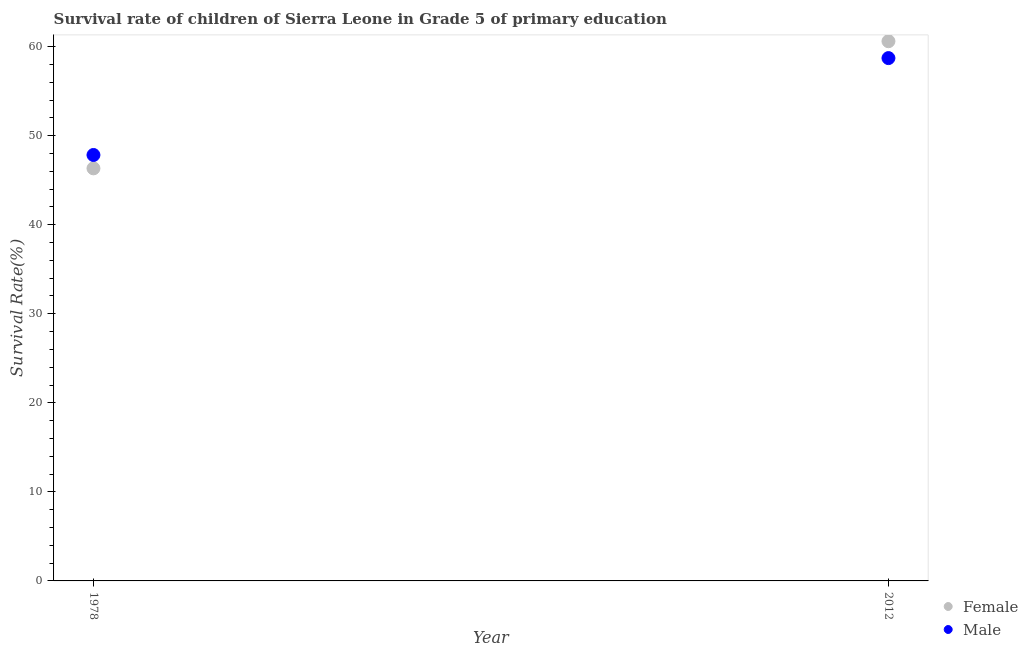How many different coloured dotlines are there?
Ensure brevity in your answer.  2. Is the number of dotlines equal to the number of legend labels?
Provide a succinct answer. Yes. What is the survival rate of female students in primary education in 2012?
Ensure brevity in your answer.  60.6. Across all years, what is the maximum survival rate of female students in primary education?
Offer a terse response. 60.6. Across all years, what is the minimum survival rate of female students in primary education?
Provide a short and direct response. 46.33. In which year was the survival rate of female students in primary education minimum?
Provide a succinct answer. 1978. What is the total survival rate of female students in primary education in the graph?
Your response must be concise. 106.93. What is the difference between the survival rate of male students in primary education in 1978 and that in 2012?
Ensure brevity in your answer.  -10.88. What is the difference between the survival rate of female students in primary education in 1978 and the survival rate of male students in primary education in 2012?
Provide a short and direct response. -12.38. What is the average survival rate of female students in primary education per year?
Provide a short and direct response. 53.47. In the year 1978, what is the difference between the survival rate of male students in primary education and survival rate of female students in primary education?
Make the answer very short. 1.5. What is the ratio of the survival rate of female students in primary education in 1978 to that in 2012?
Offer a terse response. 0.76. Is the survival rate of female students in primary education in 1978 less than that in 2012?
Your response must be concise. Yes. In how many years, is the survival rate of male students in primary education greater than the average survival rate of male students in primary education taken over all years?
Provide a short and direct response. 1. Does the survival rate of female students in primary education monotonically increase over the years?
Keep it short and to the point. Yes. Is the survival rate of male students in primary education strictly greater than the survival rate of female students in primary education over the years?
Give a very brief answer. No. How many dotlines are there?
Make the answer very short. 2. What is the difference between two consecutive major ticks on the Y-axis?
Your answer should be very brief. 10. Are the values on the major ticks of Y-axis written in scientific E-notation?
Ensure brevity in your answer.  No. Does the graph contain grids?
Your answer should be compact. No. How many legend labels are there?
Give a very brief answer. 2. How are the legend labels stacked?
Provide a succinct answer. Vertical. What is the title of the graph?
Offer a very short reply. Survival rate of children of Sierra Leone in Grade 5 of primary education. What is the label or title of the Y-axis?
Provide a succinct answer. Survival Rate(%). What is the Survival Rate(%) of Female in 1978?
Make the answer very short. 46.33. What is the Survival Rate(%) of Male in 1978?
Provide a succinct answer. 47.83. What is the Survival Rate(%) in Female in 2012?
Offer a terse response. 60.6. What is the Survival Rate(%) in Male in 2012?
Your answer should be compact. 58.71. Across all years, what is the maximum Survival Rate(%) in Female?
Keep it short and to the point. 60.6. Across all years, what is the maximum Survival Rate(%) of Male?
Your answer should be very brief. 58.71. Across all years, what is the minimum Survival Rate(%) in Female?
Your answer should be very brief. 46.33. Across all years, what is the minimum Survival Rate(%) of Male?
Offer a very short reply. 47.83. What is the total Survival Rate(%) in Female in the graph?
Offer a terse response. 106.93. What is the total Survival Rate(%) in Male in the graph?
Make the answer very short. 106.54. What is the difference between the Survival Rate(%) in Female in 1978 and that in 2012?
Provide a succinct answer. -14.27. What is the difference between the Survival Rate(%) of Male in 1978 and that in 2012?
Your answer should be compact. -10.88. What is the difference between the Survival Rate(%) in Female in 1978 and the Survival Rate(%) in Male in 2012?
Offer a terse response. -12.38. What is the average Survival Rate(%) in Female per year?
Provide a succinct answer. 53.47. What is the average Survival Rate(%) in Male per year?
Keep it short and to the point. 53.27. In the year 1978, what is the difference between the Survival Rate(%) in Female and Survival Rate(%) in Male?
Your answer should be compact. -1.5. In the year 2012, what is the difference between the Survival Rate(%) in Female and Survival Rate(%) in Male?
Offer a terse response. 1.89. What is the ratio of the Survival Rate(%) in Female in 1978 to that in 2012?
Offer a very short reply. 0.76. What is the ratio of the Survival Rate(%) of Male in 1978 to that in 2012?
Provide a succinct answer. 0.81. What is the difference between the highest and the second highest Survival Rate(%) in Female?
Your answer should be compact. 14.27. What is the difference between the highest and the second highest Survival Rate(%) of Male?
Ensure brevity in your answer.  10.88. What is the difference between the highest and the lowest Survival Rate(%) in Female?
Keep it short and to the point. 14.27. What is the difference between the highest and the lowest Survival Rate(%) in Male?
Provide a succinct answer. 10.88. 